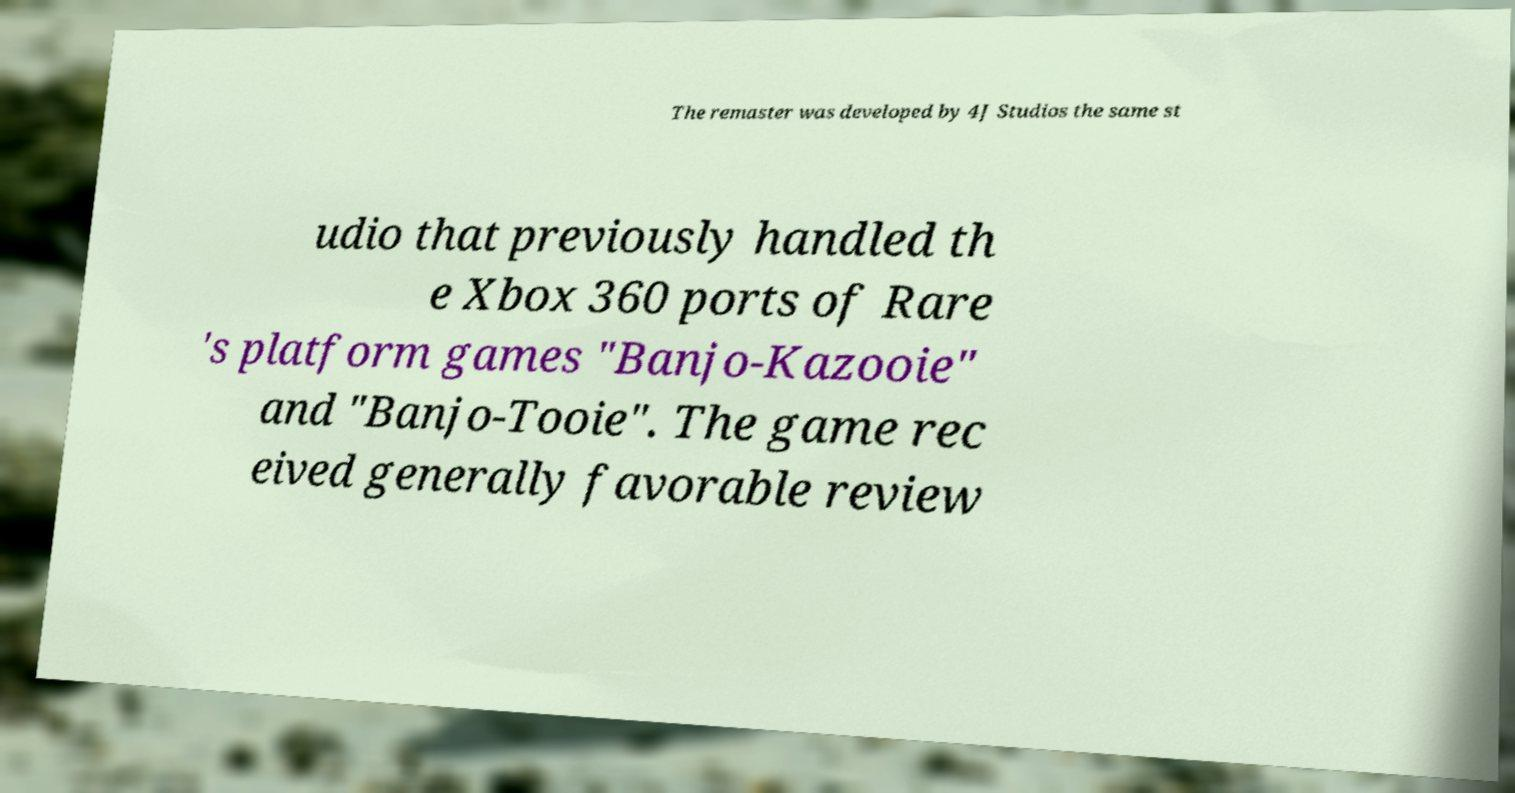Please read and relay the text visible in this image. What does it say? The remaster was developed by 4J Studios the same st udio that previously handled th e Xbox 360 ports of Rare 's platform games "Banjo-Kazooie" and "Banjo-Tooie". The game rec eived generally favorable review 